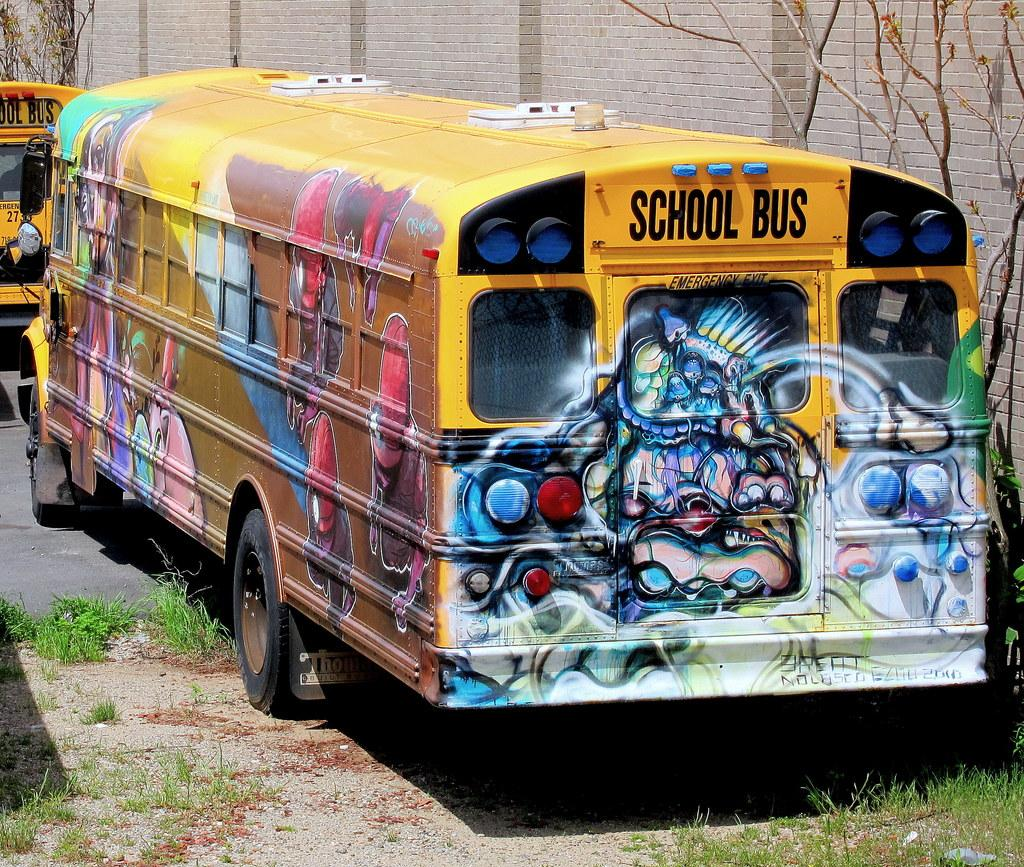What type of vehicles are on the ground in the image? There are two buses on the ground in the image. What type of natural environment is visible in the image? There is grass visible in the image, and plants are also present. What part of a tree can be seen in the image? The branches of a tree are present in the image. What type of structure is visible in the image? There is a wall in the image. How many clovers are growing on the wall in the image? There are no clovers visible in the image, as it features buses, grass, plants, tree branches, and a wall, but no clovers. 